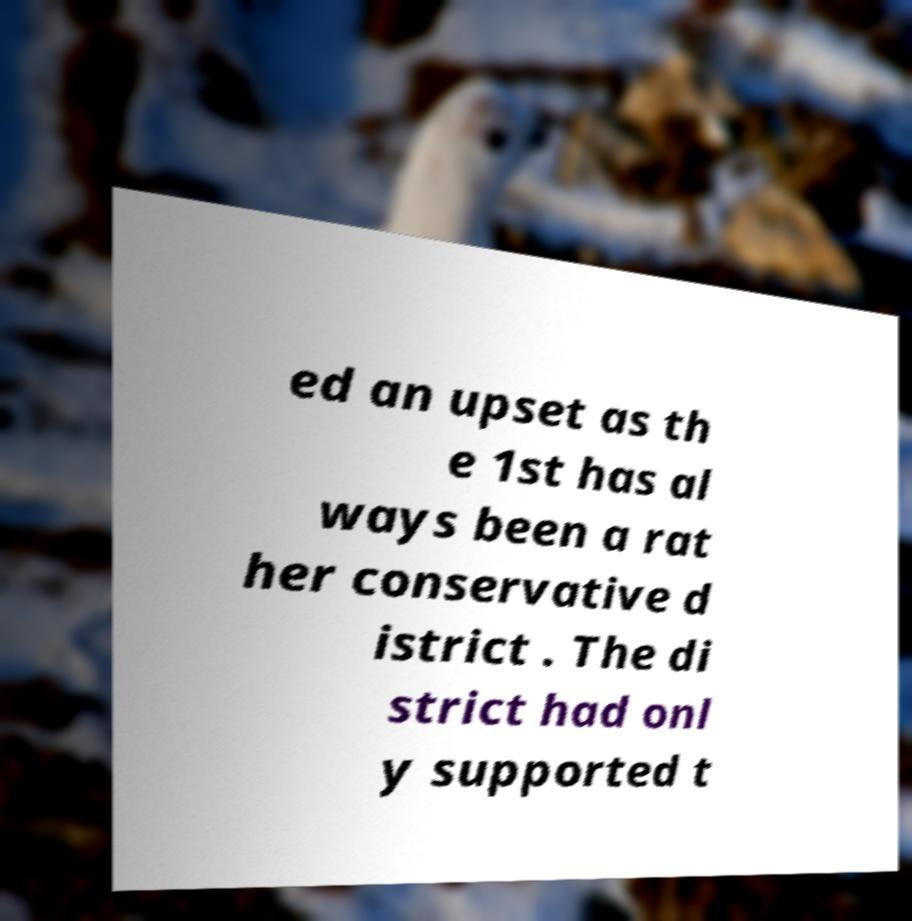Can you read and provide the text displayed in the image?This photo seems to have some interesting text. Can you extract and type it out for me? ed an upset as th e 1st has al ways been a rat her conservative d istrict . The di strict had onl y supported t 